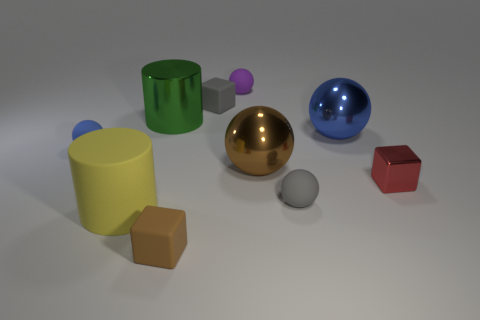Are there any patterns or consistent shapes found among the objects? Yes, there are recurring geometric shapes present. For example, we have multiple cylinders of different colors and a couple of spheres. These shapes provide a study of simple geometry and color contrast.  Do any of the objects share a color or texture? The objects all have distinct colors; however, they share a similar smooth texture, giving them a uniform aesthetic in terms of material finish. 